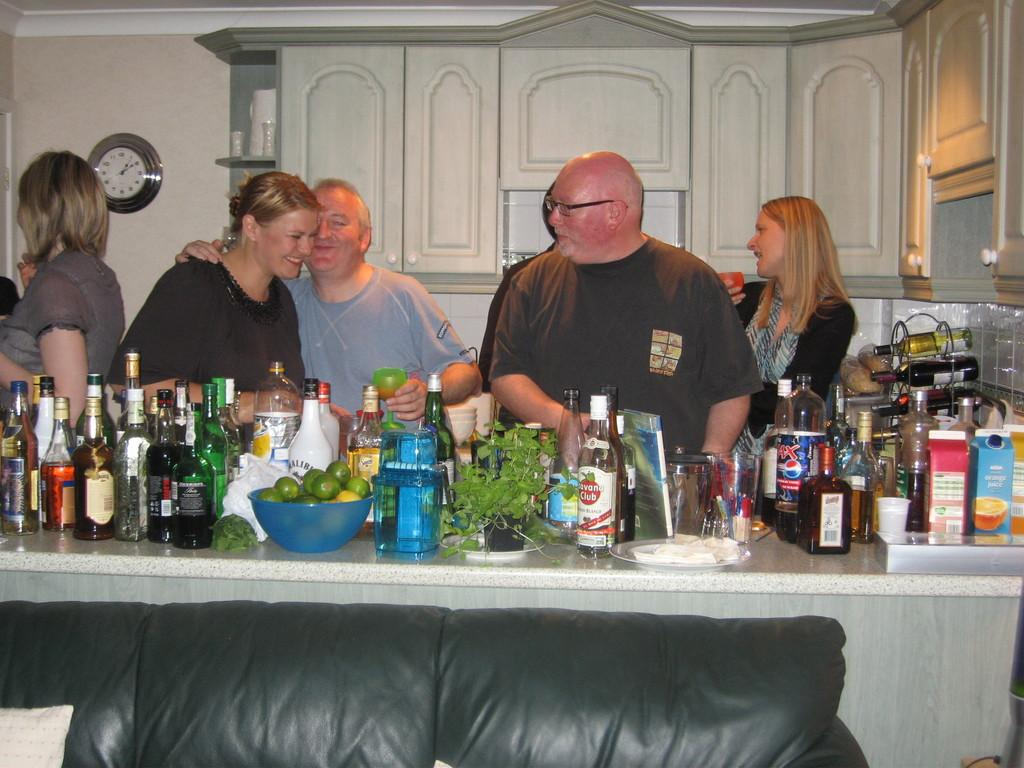<image>
Write a terse but informative summary of the picture. A gathering of men and women in a kitchen with numerous bottles of liquors on the counter top. 